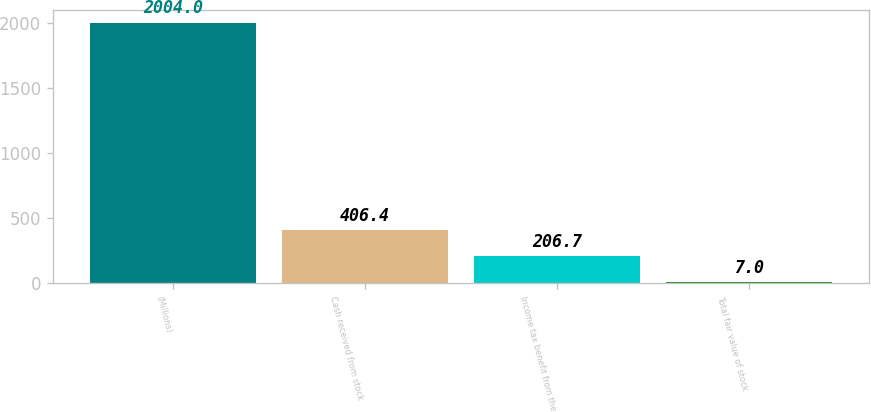Convert chart to OTSL. <chart><loc_0><loc_0><loc_500><loc_500><bar_chart><fcel>(Millions)<fcel>Cash received from stock<fcel>Income tax benefit from the<fcel>Total fair value of stock<nl><fcel>2004<fcel>406.4<fcel>206.7<fcel>7<nl></chart> 